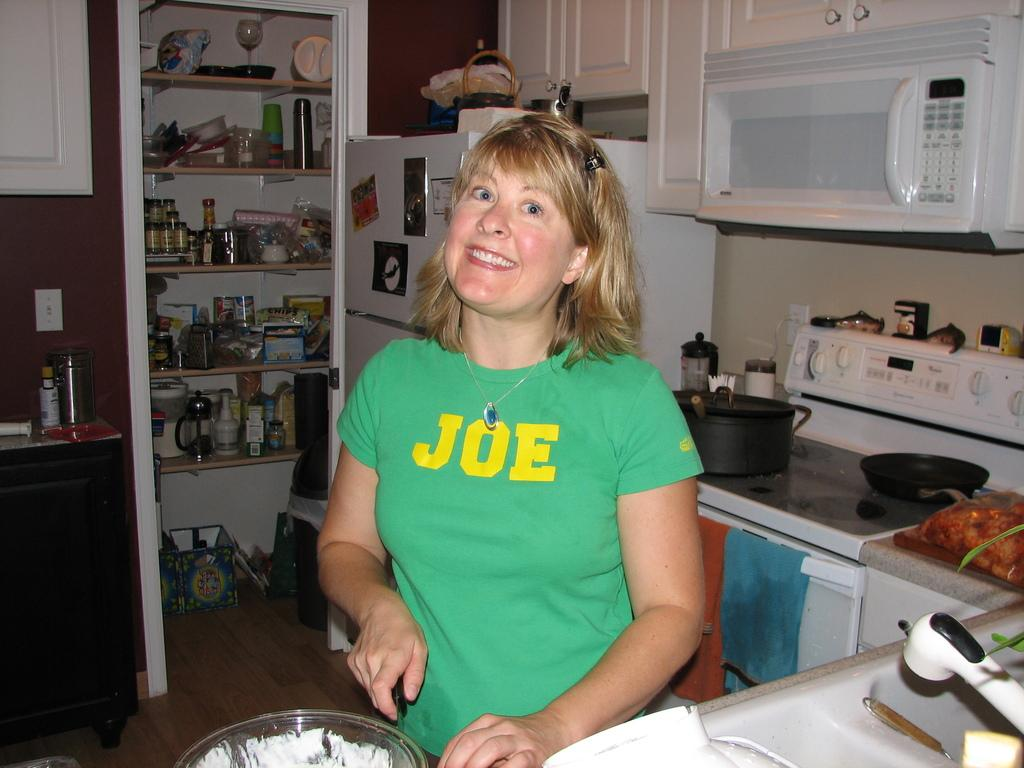<image>
Share a concise interpretation of the image provided. A woman toiling away in a kitchen wears a t-shirt with the name JOE on the front. 